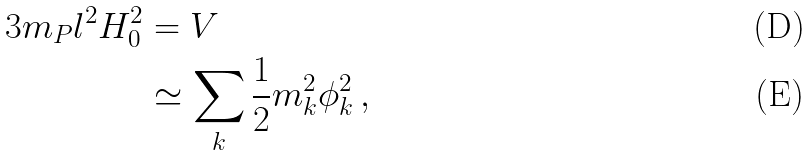Convert formula to latex. <formula><loc_0><loc_0><loc_500><loc_500>3 m _ { P } l ^ { 2 } H _ { 0 } ^ { 2 } & = V \\ & \simeq \sum _ { k } \frac { 1 } { 2 } m _ { k } ^ { 2 } \phi _ { k } ^ { 2 } \, ,</formula> 